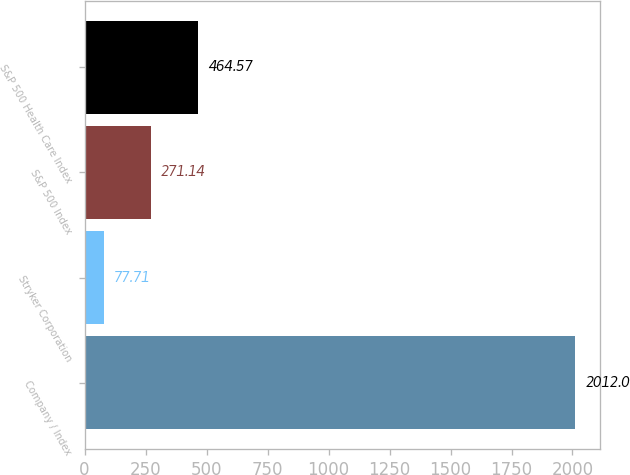<chart> <loc_0><loc_0><loc_500><loc_500><bar_chart><fcel>Company / Index<fcel>Stryker Corporation<fcel>S&P 500 Index<fcel>S&P 500 Health Care Index<nl><fcel>2012<fcel>77.71<fcel>271.14<fcel>464.57<nl></chart> 